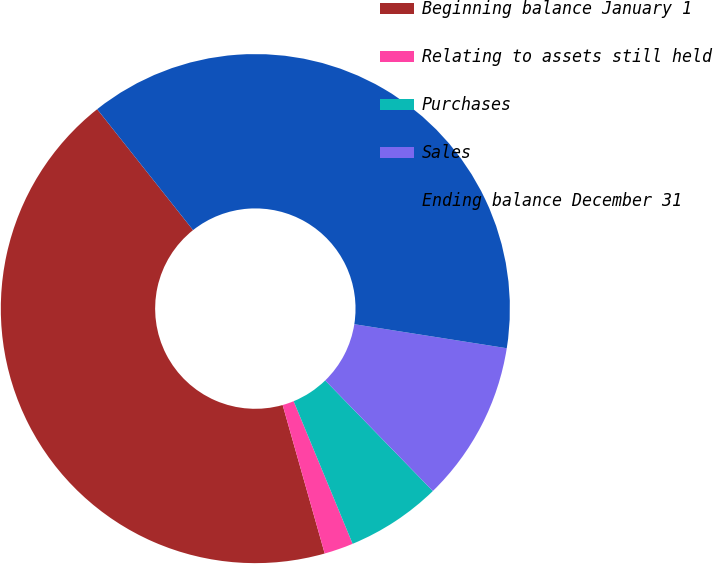Convert chart. <chart><loc_0><loc_0><loc_500><loc_500><pie_chart><fcel>Beginning balance January 1<fcel>Relating to assets still held<fcel>Purchases<fcel>Sales<fcel>Ending balance December 31<nl><fcel>43.72%<fcel>1.85%<fcel>6.04%<fcel>10.23%<fcel>38.16%<nl></chart> 